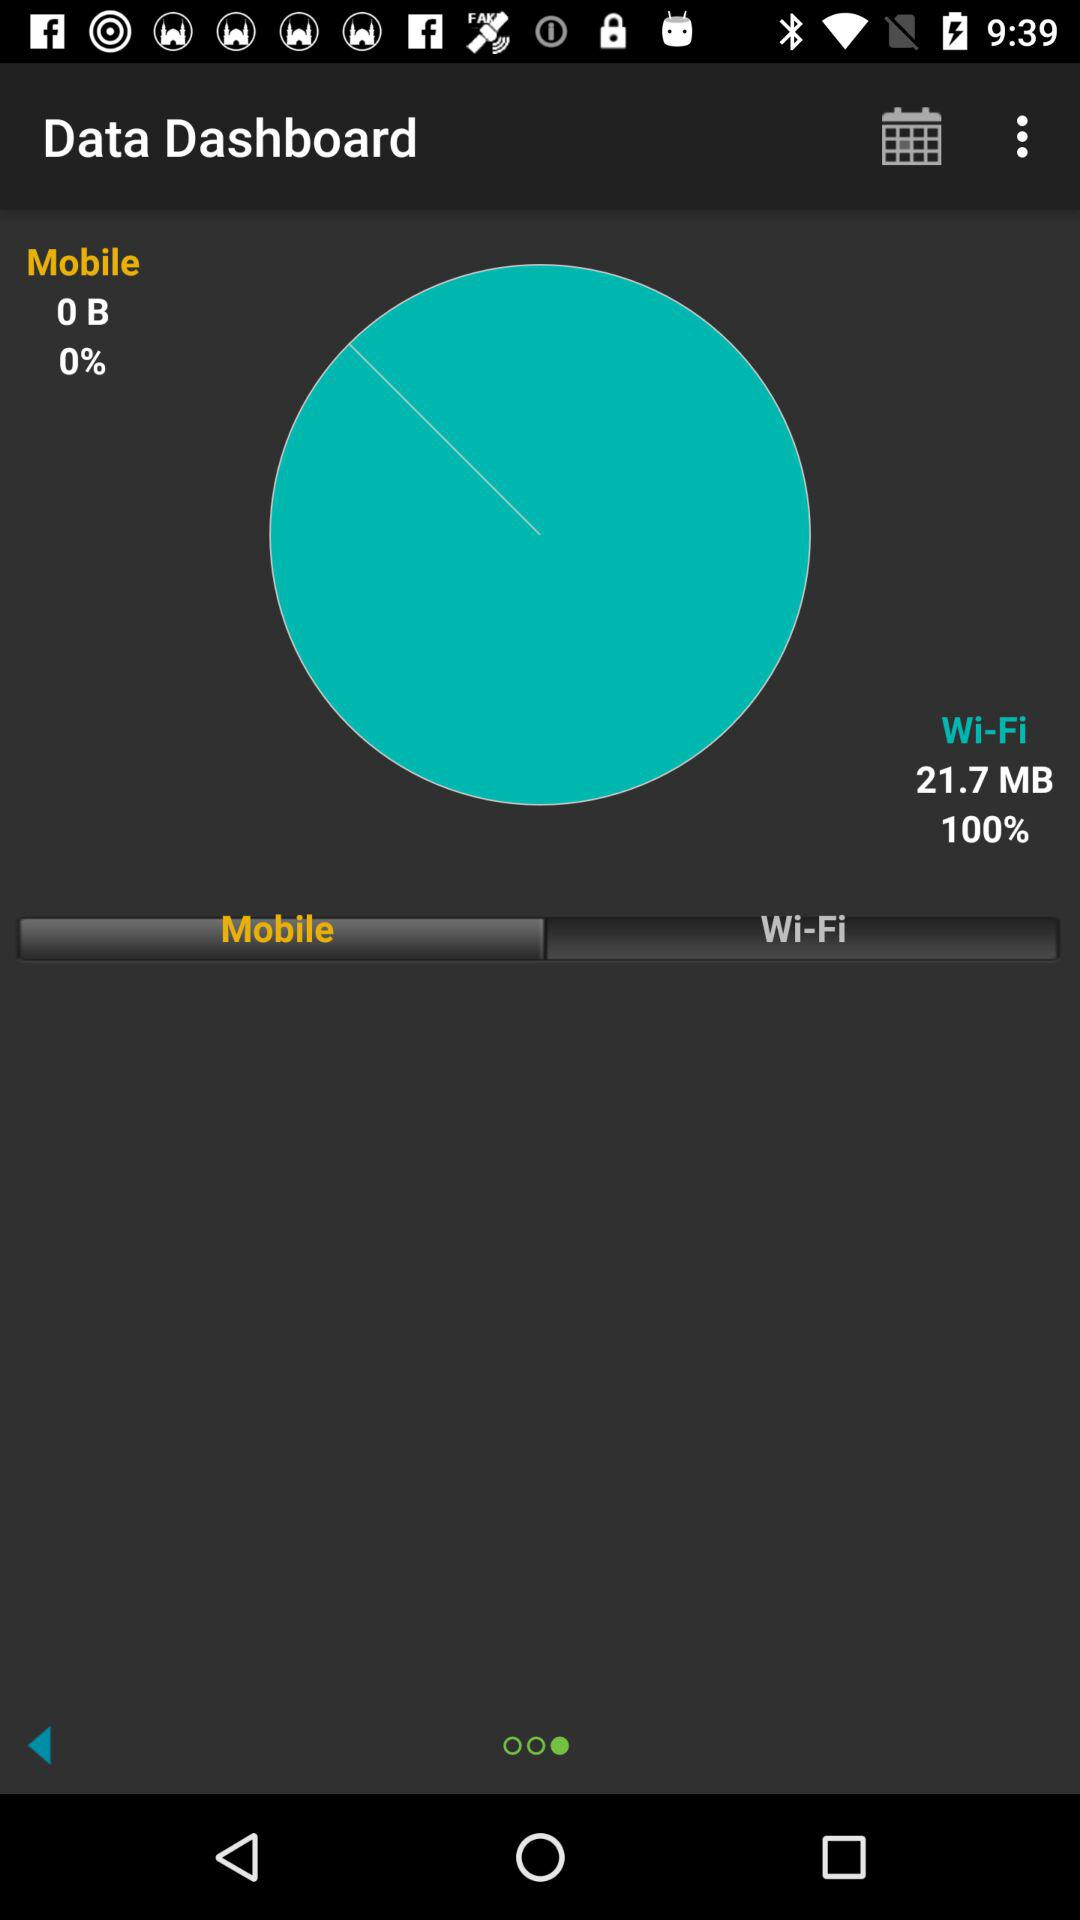On which network has 0 bytes of data been used? 0 bytes of data have been used on the "Mobile" network. 